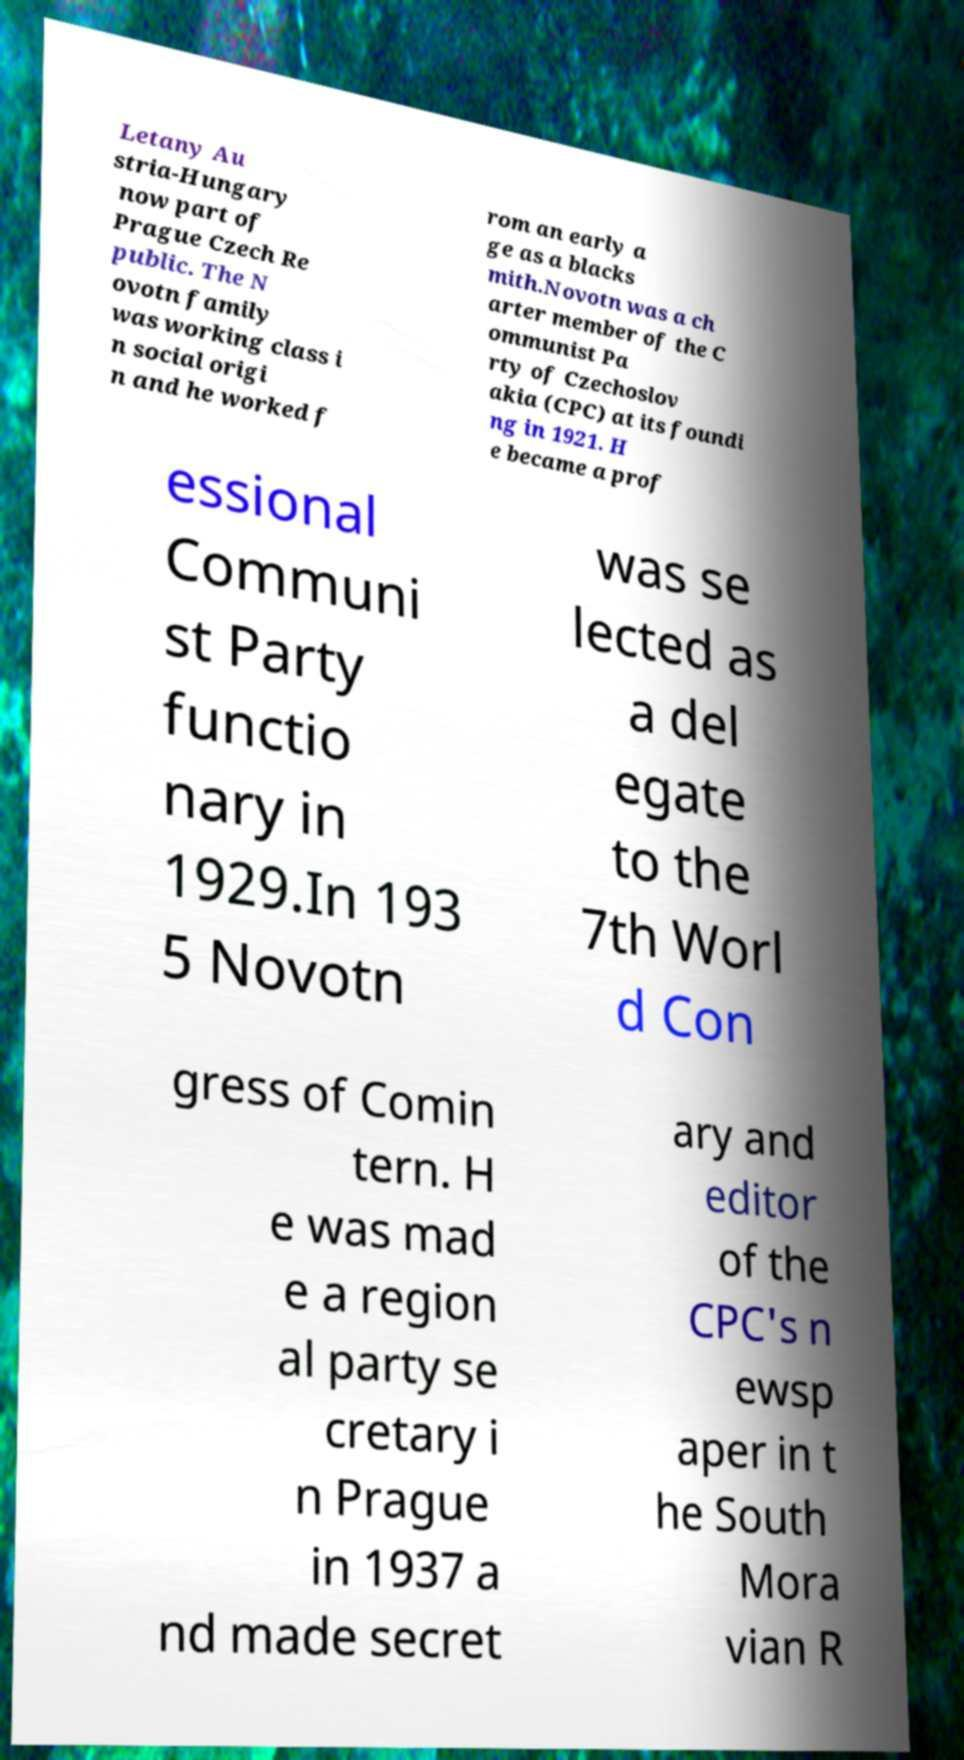Can you read and provide the text displayed in the image?This photo seems to have some interesting text. Can you extract and type it out for me? Letany Au stria-Hungary now part of Prague Czech Re public. The N ovotn family was working class i n social origi n and he worked f rom an early a ge as a blacks mith.Novotn was a ch arter member of the C ommunist Pa rty of Czechoslov akia (CPC) at its foundi ng in 1921. H e became a prof essional Communi st Party functio nary in 1929.In 193 5 Novotn was se lected as a del egate to the 7th Worl d Con gress of Comin tern. H e was mad e a region al party se cretary i n Prague in 1937 a nd made secret ary and editor of the CPC's n ewsp aper in t he South Mora vian R 